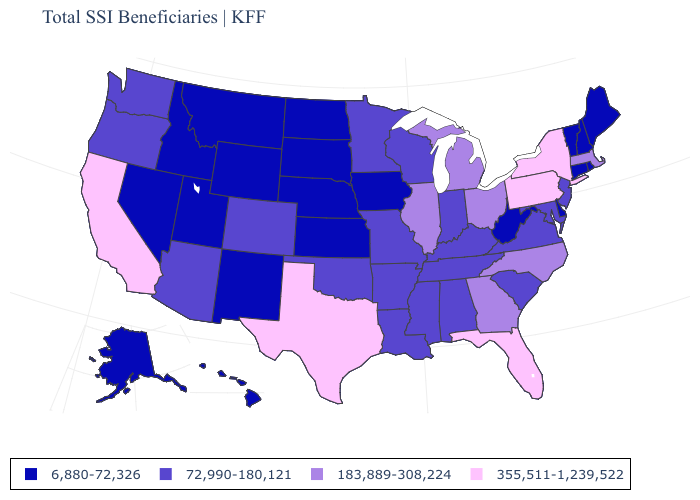What is the value of Pennsylvania?
Concise answer only. 355,511-1,239,522. Name the states that have a value in the range 355,511-1,239,522?
Keep it brief. California, Florida, New York, Pennsylvania, Texas. What is the value of Hawaii?
Give a very brief answer. 6,880-72,326. Name the states that have a value in the range 355,511-1,239,522?
Quick response, please. California, Florida, New York, Pennsylvania, Texas. What is the value of Wisconsin?
Quick response, please. 72,990-180,121. What is the value of Maryland?
Short answer required. 72,990-180,121. Among the states that border New Mexico , does Texas have the highest value?
Concise answer only. Yes. What is the lowest value in the USA?
Be succinct. 6,880-72,326. Does Maine have the lowest value in the Northeast?
Keep it brief. Yes. Name the states that have a value in the range 183,889-308,224?
Quick response, please. Georgia, Illinois, Massachusetts, Michigan, North Carolina, Ohio. What is the value of Kansas?
Keep it brief. 6,880-72,326. What is the value of Georgia?
Quick response, please. 183,889-308,224. Name the states that have a value in the range 183,889-308,224?
Give a very brief answer. Georgia, Illinois, Massachusetts, Michigan, North Carolina, Ohio. Among the states that border New York , which have the highest value?
Be succinct. Pennsylvania. 